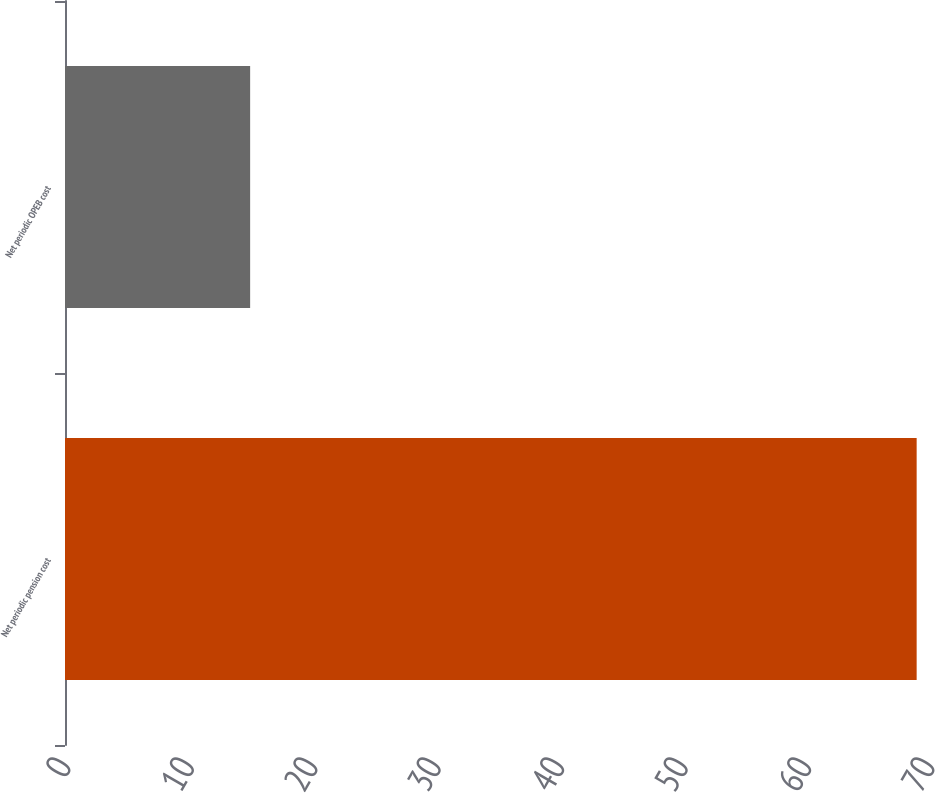Convert chart to OTSL. <chart><loc_0><loc_0><loc_500><loc_500><bar_chart><fcel>Net periodic pension cost<fcel>Net periodic OPEB cost<nl><fcel>69<fcel>15<nl></chart> 